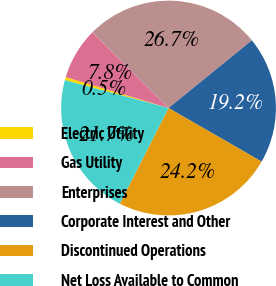<chart> <loc_0><loc_0><loc_500><loc_500><pie_chart><fcel>Electric Utility<fcel>Gas Utility<fcel>Enterprises<fcel>Corporate Interest and Other<fcel>Discontinued Operations<fcel>Net Loss Available to Common<nl><fcel>0.47%<fcel>7.79%<fcel>26.7%<fcel>19.17%<fcel>24.19%<fcel>21.68%<nl></chart> 